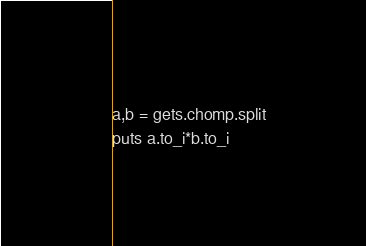Convert code to text. <code><loc_0><loc_0><loc_500><loc_500><_Ruby_>a,b = gets.chomp.split
puts a.to_i*b.to_i</code> 